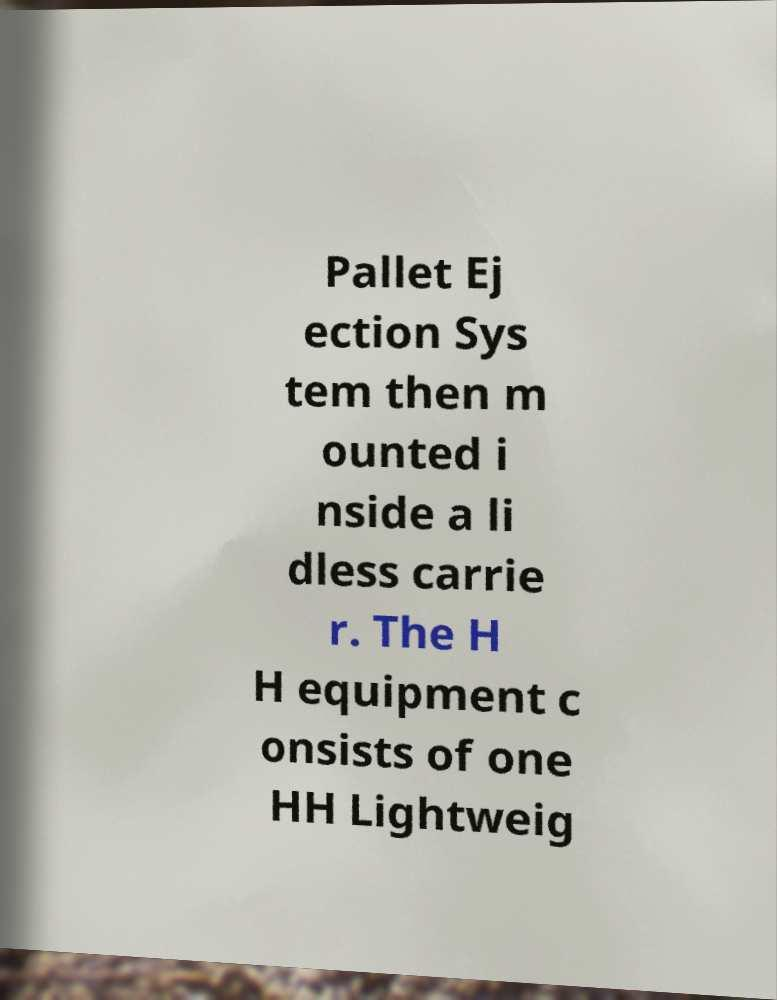There's text embedded in this image that I need extracted. Can you transcribe it verbatim? Pallet Ej ection Sys tem then m ounted i nside a li dless carrie r. The H H equipment c onsists of one HH Lightweig 